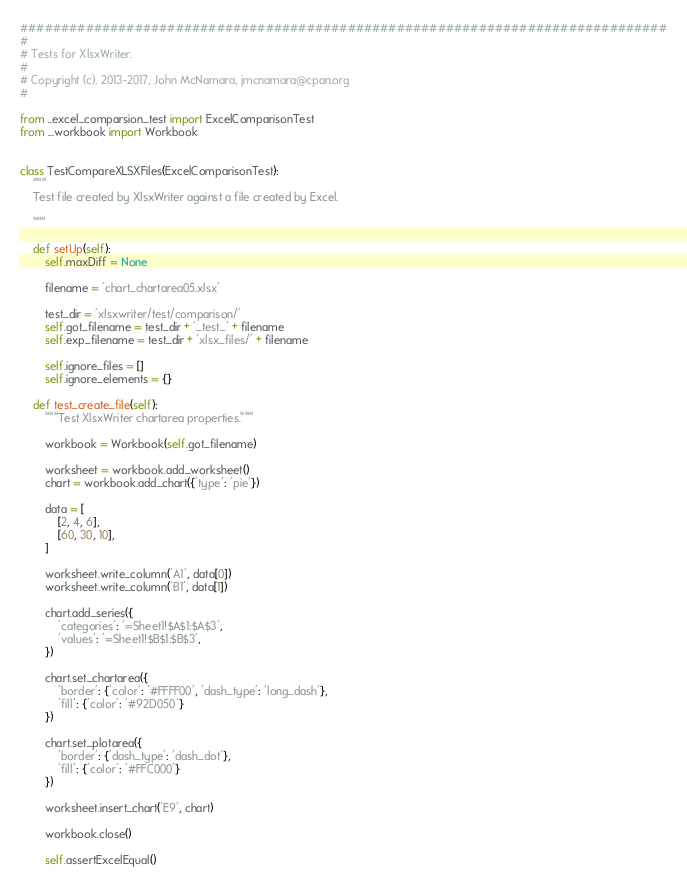Convert code to text. <code><loc_0><loc_0><loc_500><loc_500><_Python_>###############################################################################
#
# Tests for XlsxWriter.
#
# Copyright (c), 2013-2017, John McNamara, jmcnamara@cpan.org
#

from ..excel_comparsion_test import ExcelComparisonTest
from ...workbook import Workbook


class TestCompareXLSXFiles(ExcelComparisonTest):
    """
    Test file created by XlsxWriter against a file created by Excel.

    """

    def setUp(self):
        self.maxDiff = None

        filename = 'chart_chartarea05.xlsx'

        test_dir = 'xlsxwriter/test/comparison/'
        self.got_filename = test_dir + '_test_' + filename
        self.exp_filename = test_dir + 'xlsx_files/' + filename

        self.ignore_files = []
        self.ignore_elements = {}

    def test_create_file(self):
        """Test XlsxWriter chartarea properties."""

        workbook = Workbook(self.got_filename)

        worksheet = workbook.add_worksheet()
        chart = workbook.add_chart({'type': 'pie'})

        data = [
            [2, 4, 6],
            [60, 30, 10],
        ]

        worksheet.write_column('A1', data[0])
        worksheet.write_column('B1', data[1])

        chart.add_series({
            'categories': '=Sheet1!$A$1:$A$3',
            'values': '=Sheet1!$B$1:$B$3',
        })

        chart.set_chartarea({
            'border': {'color': '#FFFF00', 'dash_type': 'long_dash'},
            'fill': {'color': '#92D050'}
        })

        chart.set_plotarea({
            'border': {'dash_type': 'dash_dot'},
            'fill': {'color': '#FFC000'}
        })

        worksheet.insert_chart('E9', chart)

        workbook.close()

        self.assertExcelEqual()
</code> 